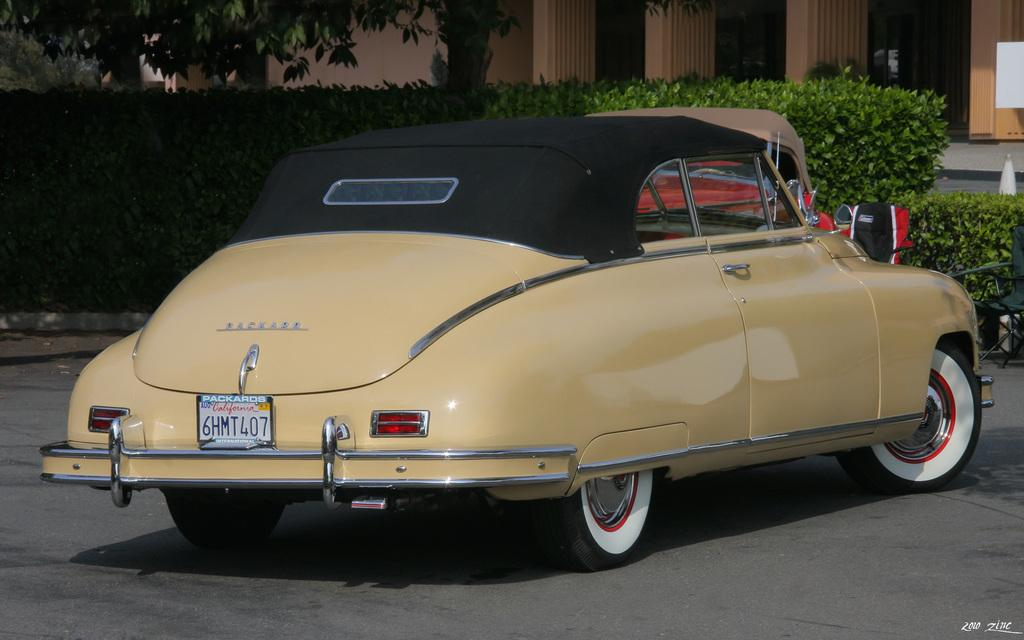What is the main subject of the image? There is a car in the image. Where is the car located? The car is on the road. What color is the car? The car is yellow. What can be seen in the background of the image? There are plants, trees, and a building in the background of the image. What type of coat is the car wearing in the image? Cars do not wear coats; the question is not applicable to the image. 